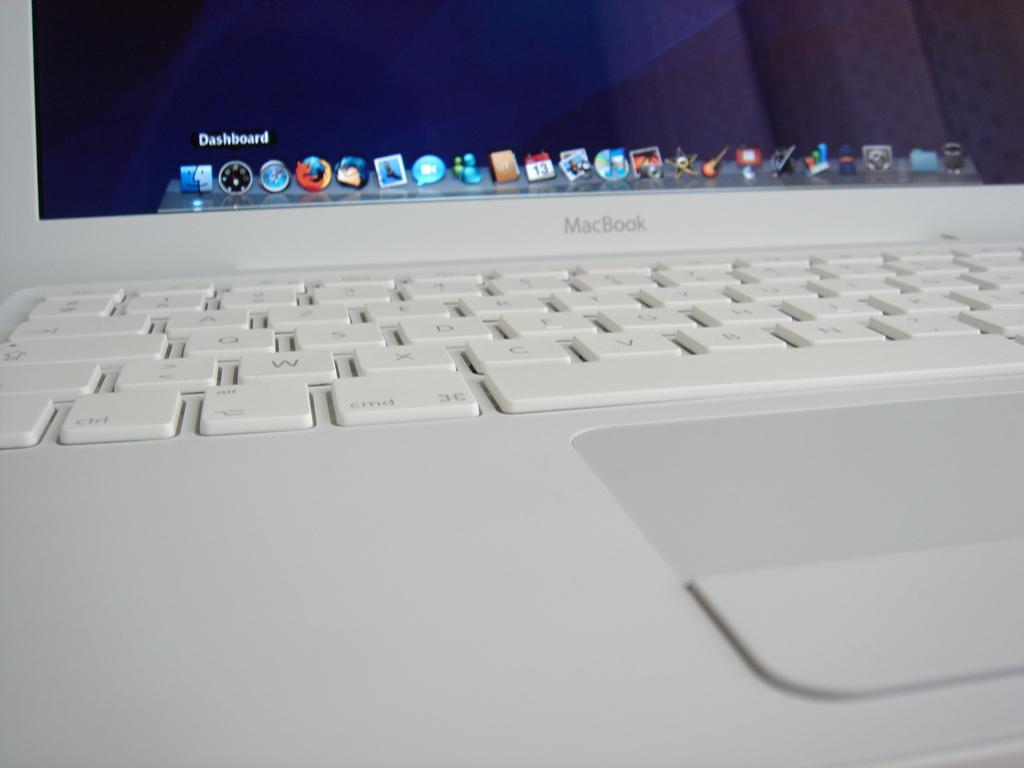<image>
Share a concise interpretation of the image provided. A white MacBook laptop is on a table and is displaying the Dashboard. 